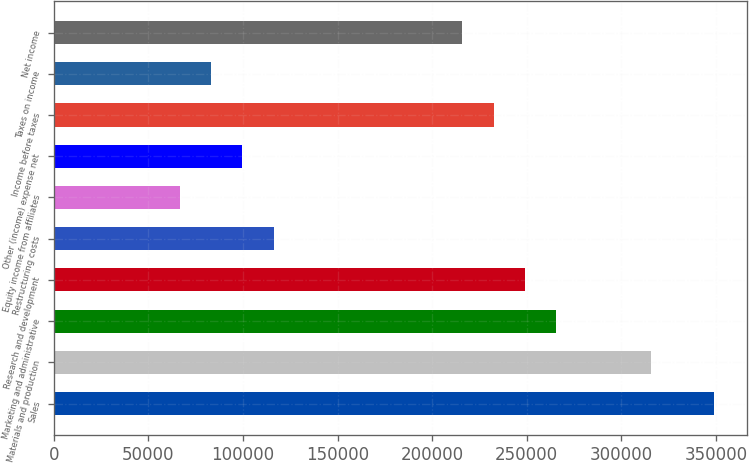Convert chart. <chart><loc_0><loc_0><loc_500><loc_500><bar_chart><fcel>Sales<fcel>Materials and production<fcel>Marketing and administrative<fcel>Research and development<fcel>Restructuring costs<fcel>Equity income from affiliates<fcel>Other (income) expense net<fcel>Income before taxes<fcel>Taxes on income<fcel>Net income<nl><fcel>348808<fcel>315589<fcel>265759<fcel>249149<fcel>116270<fcel>66440.9<fcel>99660.6<fcel>232539<fcel>83050.8<fcel>215929<nl></chart> 